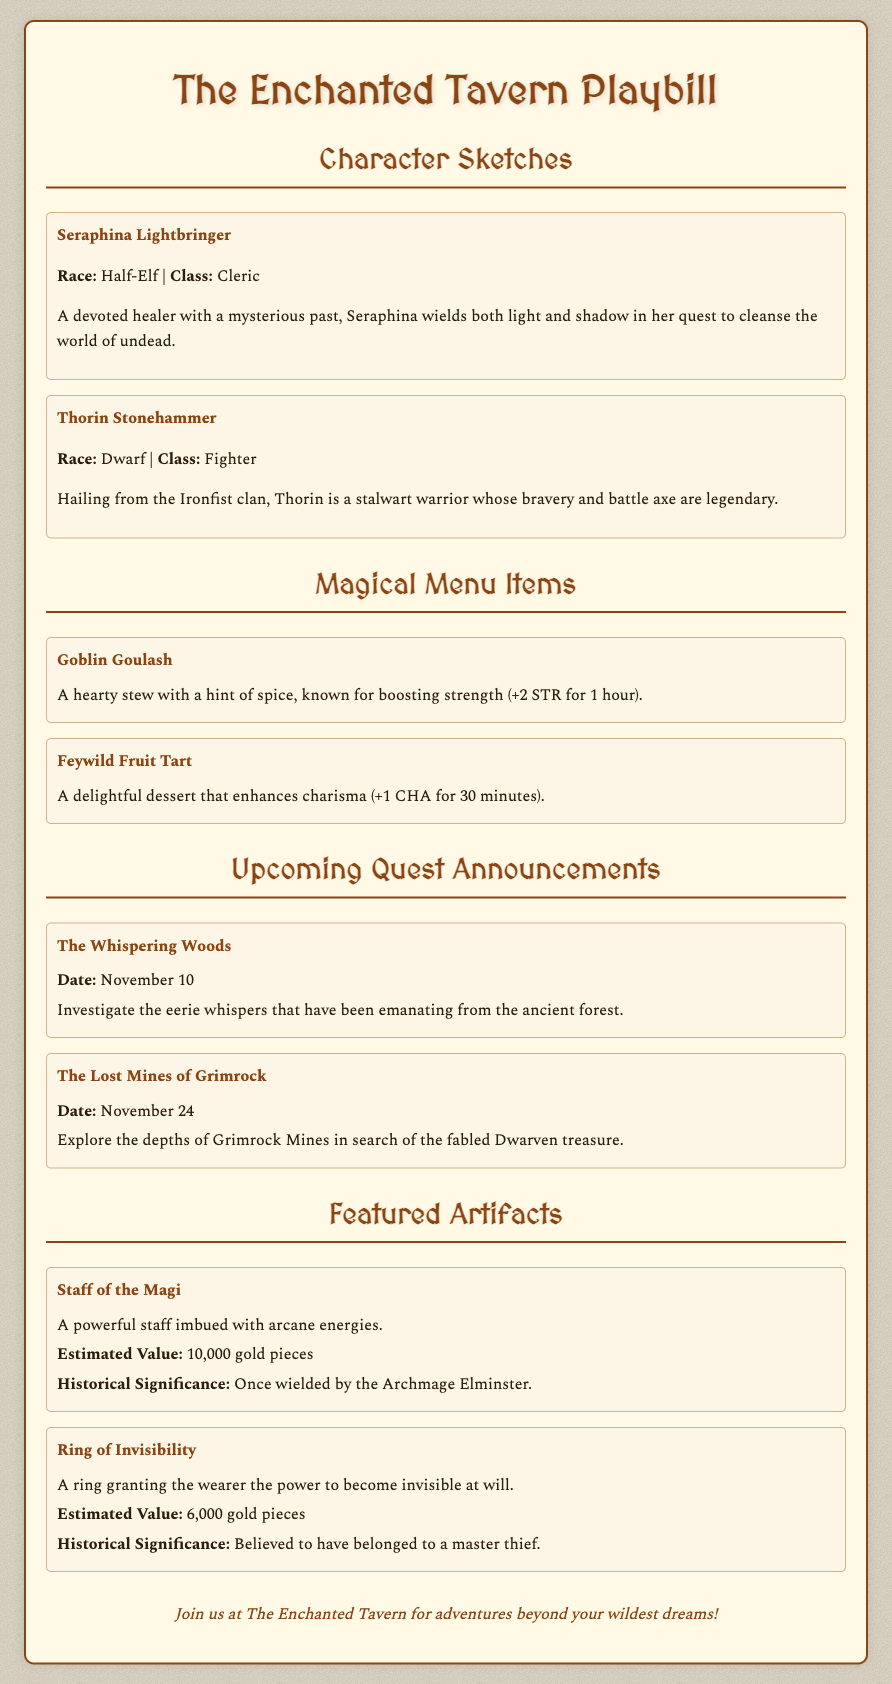What is the title of the playbill? The title is prominently displayed at the top of the document.
Answer: The Enchanted Tavern Playbill Who is the character classified as a Cleric? This information can be found in the Character Sketches section where the character details are provided.
Answer: Seraphina Lightbringer What date is the quest "The Lost Mines of Grimrock" scheduled for? The date is mentioned alongside the quest title in the Upcoming Quest Announcements section.
Answer: November 24 What is the estimated value of the Staff of the Magi? This figure is listed in the Featured Artifacts section next to the artifact name.
Answer: 10,000 gold pieces Which magical menu item enhances charisma? The name of the item associated with charisma enhancement is found in the Magical Menu Items section.
Answer: Feywild Fruit Tart What type of item is the Ring of Invisibility? The item type can be determined from the context and description provided in the Featured Artifacts section.
Answer: Ring Who is the legendary warrior from the Ironfist clan? This character's name is included in the Character Sketches section.
Answer: Thorin Stonehammer What effect does the Goblin Goulash provide? The specific effect of the item can be found in its description within the Magical Menu Items section.
Answer: +2 STR for 1 hour 